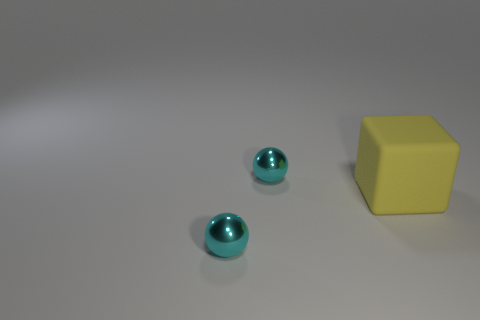Add 1 yellow cubes. How many objects exist? 4 Subtract all balls. How many objects are left? 1 Subtract all cyan metal balls. Subtract all rubber objects. How many objects are left? 0 Add 2 big yellow cubes. How many big yellow cubes are left? 3 Add 1 big yellow things. How many big yellow things exist? 2 Subtract 0 green cubes. How many objects are left? 3 